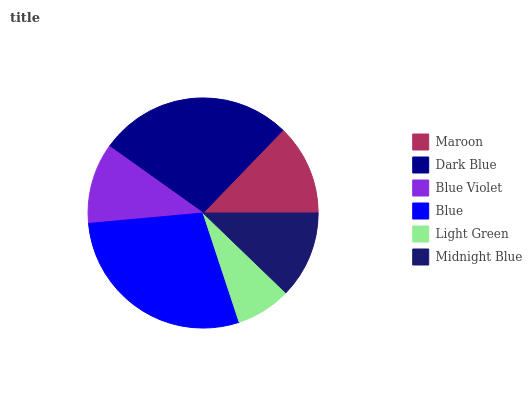Is Light Green the minimum?
Answer yes or no. Yes. Is Blue the maximum?
Answer yes or no. Yes. Is Dark Blue the minimum?
Answer yes or no. No. Is Dark Blue the maximum?
Answer yes or no. No. Is Dark Blue greater than Maroon?
Answer yes or no. Yes. Is Maroon less than Dark Blue?
Answer yes or no. Yes. Is Maroon greater than Dark Blue?
Answer yes or no. No. Is Dark Blue less than Maroon?
Answer yes or no. No. Is Maroon the high median?
Answer yes or no. Yes. Is Midnight Blue the low median?
Answer yes or no. Yes. Is Blue Violet the high median?
Answer yes or no. No. Is Dark Blue the low median?
Answer yes or no. No. 